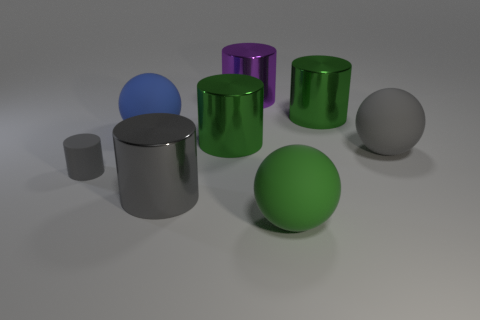Are there any blue rubber spheres behind the large gray metallic cylinder?
Offer a very short reply. Yes. The big gray object to the left of the matte object to the right of the green sphere is made of what material?
Your answer should be compact. Metal. What is the size of the gray rubber object that is the same shape as the purple thing?
Offer a very short reply. Small. What color is the metallic object that is both behind the tiny matte cylinder and in front of the large blue matte ball?
Keep it short and to the point. Green. Is the size of the sphere to the left of the purple object the same as the tiny object?
Ensure brevity in your answer.  No. Is there anything else that has the same shape as the big purple object?
Provide a short and direct response. Yes. Does the large purple cylinder have the same material as the gray thing that is in front of the gray matte cylinder?
Ensure brevity in your answer.  Yes. What number of blue objects are either tiny matte cylinders or cylinders?
Your response must be concise. 0. Are any large green matte objects visible?
Provide a short and direct response. Yes. Is there a big gray sphere that is to the left of the thing that is behind the green metallic object to the right of the purple metallic cylinder?
Your answer should be compact. No. 